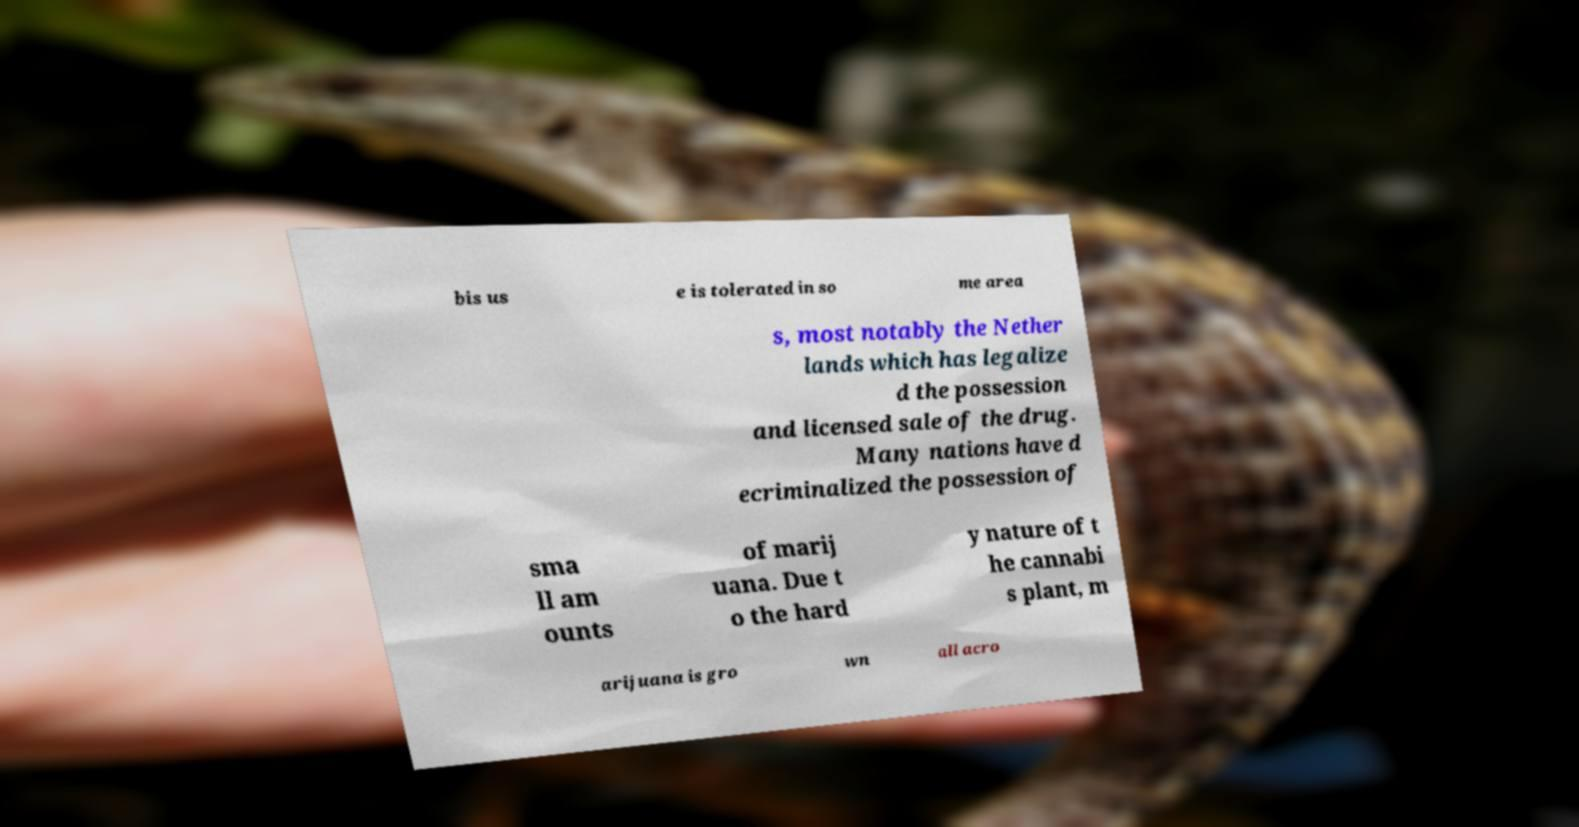Could you extract and type out the text from this image? bis us e is tolerated in so me area s, most notably the Nether lands which has legalize d the possession and licensed sale of the drug. Many nations have d ecriminalized the possession of sma ll am ounts of marij uana. Due t o the hard y nature of t he cannabi s plant, m arijuana is gro wn all acro 